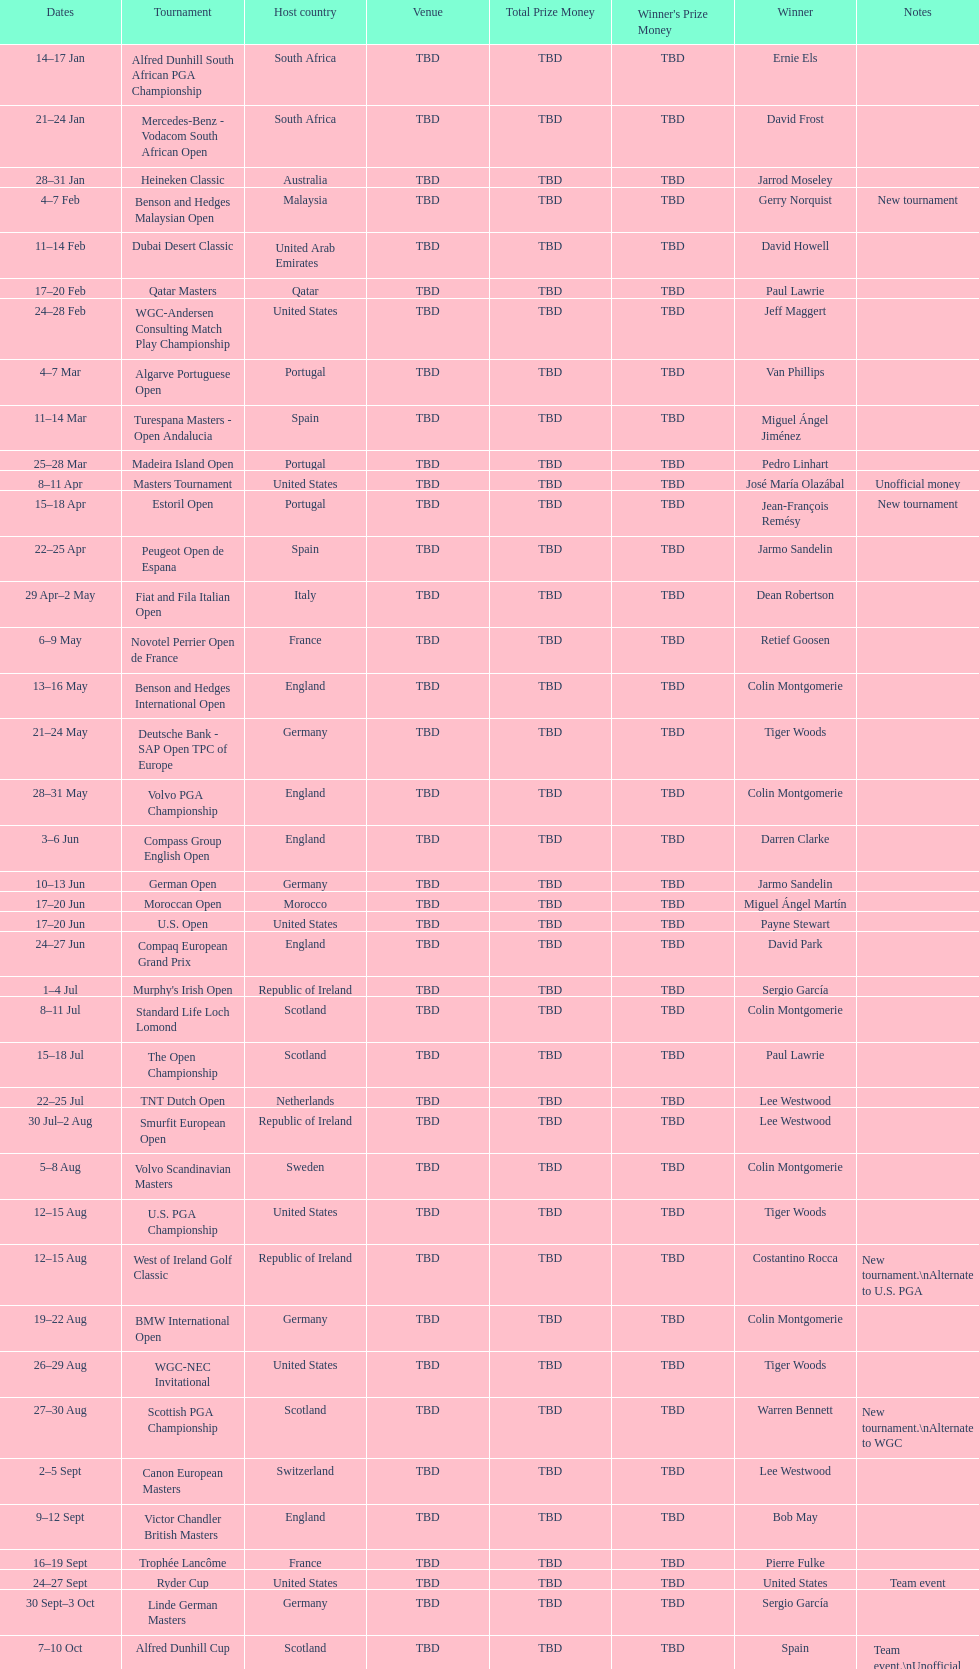How many tournaments began before aug 15th 31. 